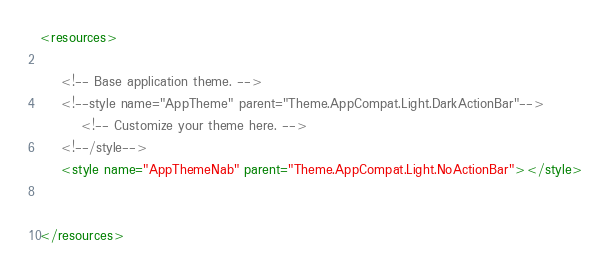Convert code to text. <code><loc_0><loc_0><loc_500><loc_500><_XML_><resources>

    <!-- Base application theme. -->
    <!--style name="AppTheme" parent="Theme.AppCompat.Light.DarkActionBar"-->
        <!-- Customize your theme here. -->
    <!--/style-->
    <style name="AppThemeNab" parent="Theme.AppCompat.Light.NoActionBar"></style>


</resources>
</code> 